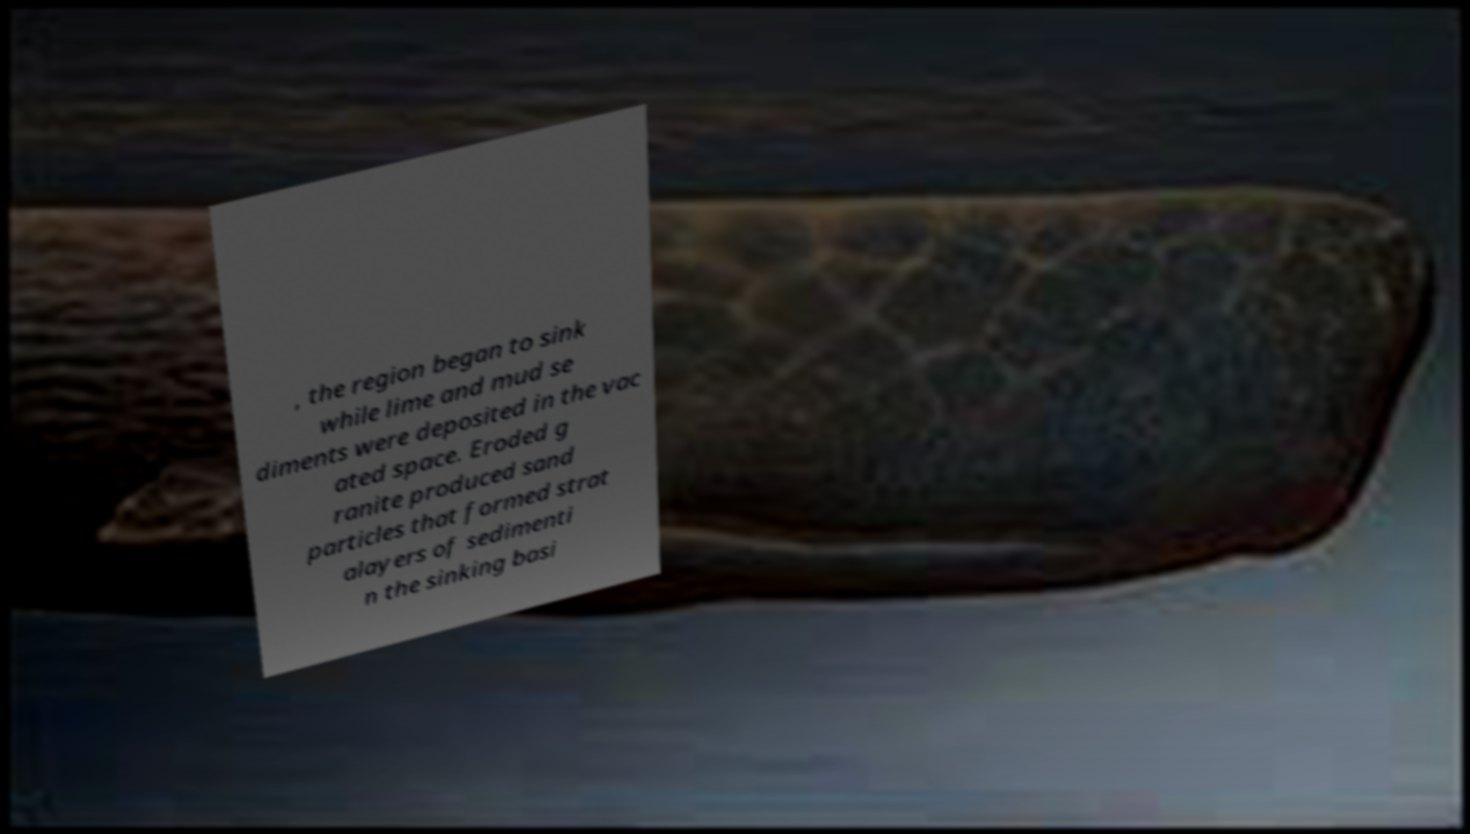What messages or text are displayed in this image? I need them in a readable, typed format. , the region began to sink while lime and mud se diments were deposited in the vac ated space. Eroded g ranite produced sand particles that formed strat alayers of sedimenti n the sinking basi 